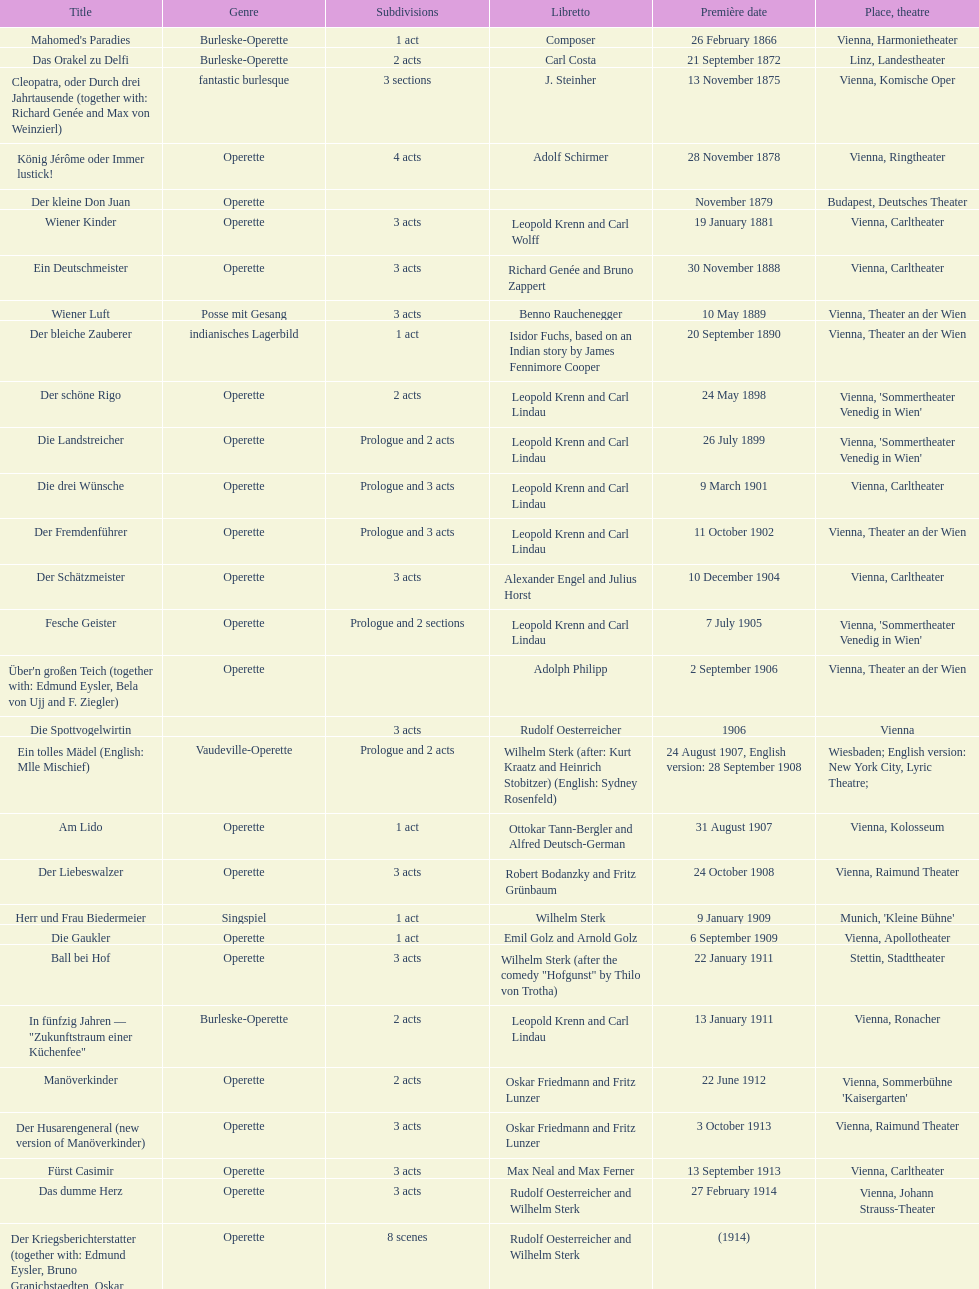Could you parse the entire table as a dict? {'header': ['Title', 'Genre', 'Sub\xaddivisions', 'Libretto', 'Première date', 'Place, theatre'], 'rows': [["Mahomed's Paradies", 'Burleske-Operette', '1 act', 'Composer', '26 February 1866', 'Vienna, Harmonietheater'], ['Das Orakel zu Delfi', 'Burleske-Operette', '2 acts', 'Carl Costa', '21 September 1872', 'Linz, Landestheater'], ['Cleopatra, oder Durch drei Jahrtausende (together with: Richard Genée and Max von Weinzierl)', 'fantastic burlesque', '3 sections', 'J. Steinher', '13 November 1875', 'Vienna, Komische Oper'], ['König Jérôme oder Immer lustick!', 'Operette', '4 acts', 'Adolf Schirmer', '28 November 1878', 'Vienna, Ringtheater'], ['Der kleine Don Juan', 'Operette', '', '', 'November 1879', 'Budapest, Deutsches Theater'], ['Wiener Kinder', 'Operette', '3 acts', 'Leopold Krenn and Carl Wolff', '19 January 1881', 'Vienna, Carltheater'], ['Ein Deutschmeister', 'Operette', '3 acts', 'Richard Genée and Bruno Zappert', '30 November 1888', 'Vienna, Carltheater'], ['Wiener Luft', 'Posse mit Gesang', '3 acts', 'Benno Rauchenegger', '10 May 1889', 'Vienna, Theater an der Wien'], ['Der bleiche Zauberer', 'indianisches Lagerbild', '1 act', 'Isidor Fuchs, based on an Indian story by James Fennimore Cooper', '20 September 1890', 'Vienna, Theater an der Wien'], ['Der schöne Rigo', 'Operette', '2 acts', 'Leopold Krenn and Carl Lindau', '24 May 1898', "Vienna, 'Sommertheater Venedig in Wien'"], ['Die Landstreicher', 'Operette', 'Prologue and 2 acts', 'Leopold Krenn and Carl Lindau', '26 July 1899', "Vienna, 'Sommertheater Venedig in Wien'"], ['Die drei Wünsche', 'Operette', 'Prologue and 3 acts', 'Leopold Krenn and Carl Lindau', '9 March 1901', 'Vienna, Carltheater'], ['Der Fremdenführer', 'Operette', 'Prologue and 3 acts', 'Leopold Krenn and Carl Lindau', '11 October 1902', 'Vienna, Theater an der Wien'], ['Der Schätzmeister', 'Operette', '3 acts', 'Alexander Engel and Julius Horst', '10 December 1904', 'Vienna, Carltheater'], ['Fesche Geister', 'Operette', 'Prologue and 2 sections', 'Leopold Krenn and Carl Lindau', '7 July 1905', "Vienna, 'Sommertheater Venedig in Wien'"], ["Über'n großen Teich (together with: Edmund Eysler, Bela von Ujj and F. Ziegler)", 'Operette', '', 'Adolph Philipp', '2 September 1906', 'Vienna, Theater an der Wien'], ['Die Spottvogelwirtin', '', '3 acts', 'Rudolf Oesterreicher', '1906', 'Vienna'], ['Ein tolles Mädel (English: Mlle Mischief)', 'Vaudeville-Operette', 'Prologue and 2 acts', 'Wilhelm Sterk (after: Kurt Kraatz and Heinrich Stobitzer) (English: Sydney Rosenfeld)', '24 August 1907, English version: 28 September 1908', 'Wiesbaden; English version: New York City, Lyric Theatre;'], ['Am Lido', 'Operette', '1 act', 'Ottokar Tann-Bergler and Alfred Deutsch-German', '31 August 1907', 'Vienna, Kolosseum'], ['Der Liebeswalzer', 'Operette', '3 acts', 'Robert Bodanzky and Fritz Grünbaum', '24 October 1908', 'Vienna, Raimund Theater'], ['Herr und Frau Biedermeier', 'Singspiel', '1 act', 'Wilhelm Sterk', '9 January 1909', "Munich, 'Kleine Bühne'"], ['Die Gaukler', 'Operette', '1 act', 'Emil Golz and Arnold Golz', '6 September 1909', 'Vienna, Apollotheater'], ['Ball bei Hof', 'Operette', '3 acts', 'Wilhelm Sterk (after the comedy "Hofgunst" by Thilo von Trotha)', '22 January 1911', 'Stettin, Stadttheater'], ['In fünfzig Jahren — "Zukunftstraum einer Küchenfee"', 'Burleske-Operette', '2 acts', 'Leopold Krenn and Carl Lindau', '13 January 1911', 'Vienna, Ronacher'], ['Manöverkinder', 'Operette', '2 acts', 'Oskar Friedmann and Fritz Lunzer', '22 June 1912', "Vienna, Sommerbühne 'Kaisergarten'"], ['Der Husarengeneral (new version of Manöverkinder)', 'Operette', '3 acts', 'Oskar Friedmann and Fritz Lunzer', '3 October 1913', 'Vienna, Raimund Theater'], ['Fürst Casimir', 'Operette', '3 acts', 'Max Neal and Max Ferner', '13 September 1913', 'Vienna, Carltheater'], ['Das dumme Herz', 'Operette', '3 acts', 'Rudolf Oesterreicher and Wilhelm Sterk', '27 February 1914', 'Vienna, Johann Strauss-Theater'], ['Der Kriegsberichterstatter (together with: Edmund Eysler, Bruno Granichstaedten, Oskar Nedbal, Charles Weinberger)', 'Operette', '8 scenes', 'Rudolf Oesterreicher and Wilhelm Sterk', '(1914)', ''], ['Im siebenten Himmel', 'Operette', '3 acts', 'Max Neal and Max Ferner', '26 February 1916', 'Munich, Theater am Gärtnerplatz'], ['Deutschmeisterkapelle', 'Operette', '', 'Hubert Marischka and Rudolf Oesterreicher', '30 May 1958', 'Vienna, Raimund Theater'], ['Die verliebte Eskadron', 'Operette', '3 acts', 'Wilhelm Sterk (after B. Buchbinder)', '11 July 1930', 'Vienna, Johann-Strauß-Theater']]} Which year did he release his last operetta? 1930. 